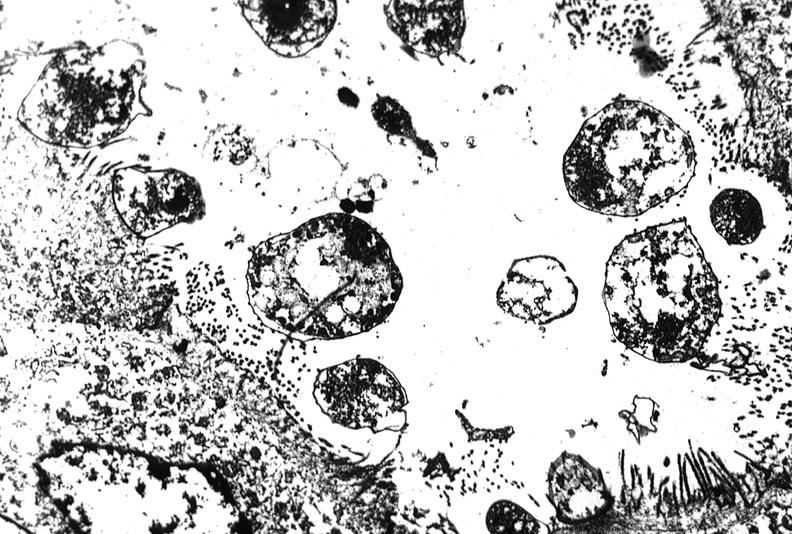s gastrointestinal present?
Answer the question using a single word or phrase. Yes 